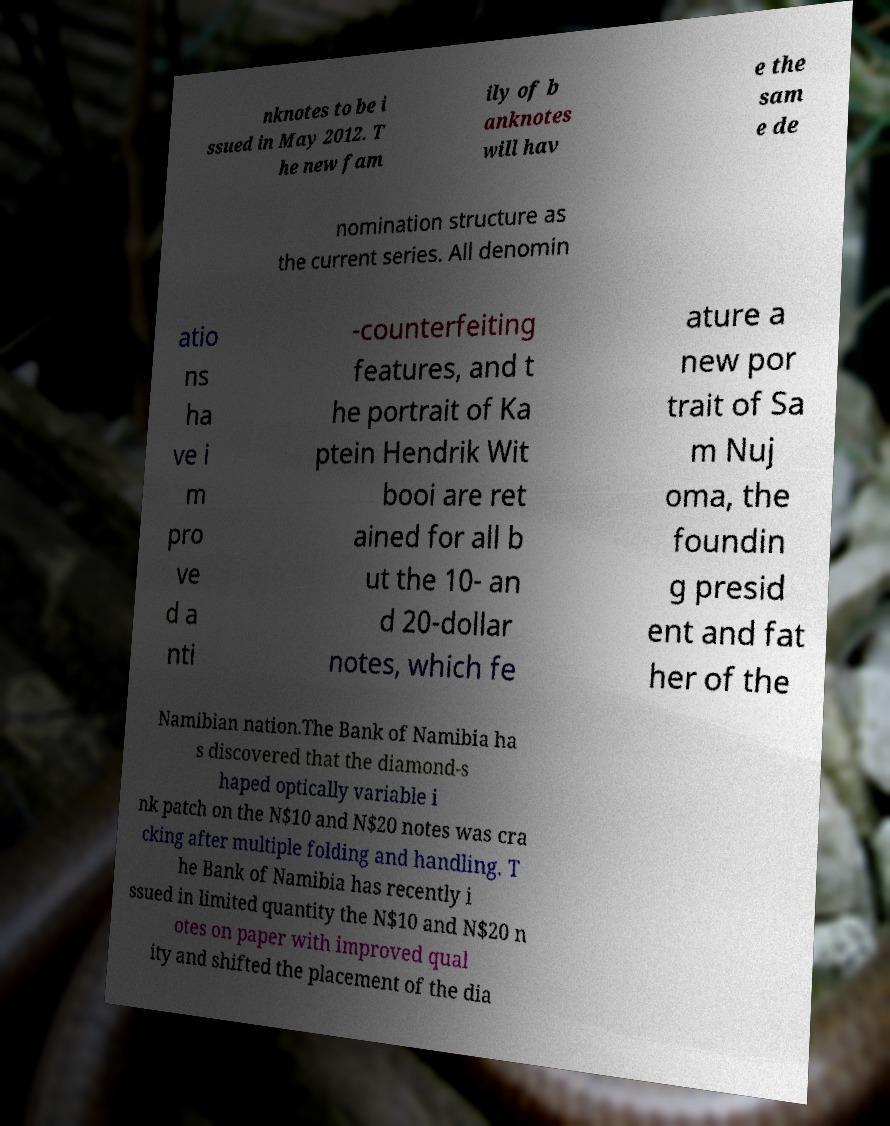Can you read and provide the text displayed in the image?This photo seems to have some interesting text. Can you extract and type it out for me? nknotes to be i ssued in May 2012. T he new fam ily of b anknotes will hav e the sam e de nomination structure as the current series. All denomin atio ns ha ve i m pro ve d a nti -counterfeiting features, and t he portrait of Ka ptein Hendrik Wit booi are ret ained for all b ut the 10- an d 20-dollar notes, which fe ature a new por trait of Sa m Nuj oma, the foundin g presid ent and fat her of the Namibian nation.The Bank of Namibia ha s discovered that the diamond-s haped optically variable i nk patch on the N$10 and N$20 notes was cra cking after multiple folding and handling. T he Bank of Namibia has recently i ssued in limited quantity the N$10 and N$20 n otes on paper with improved qual ity and shifted the placement of the dia 